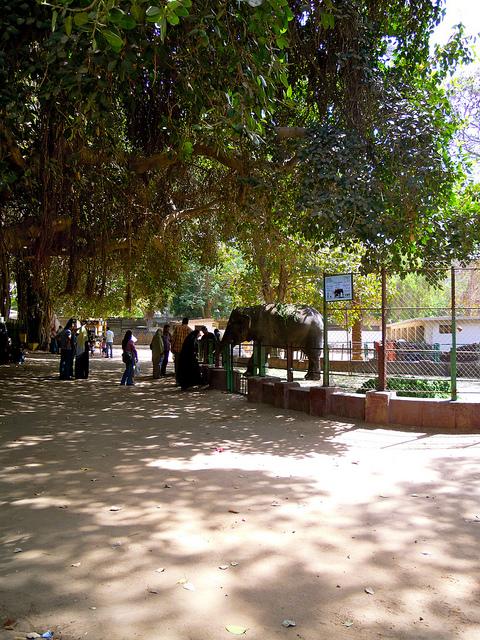What shades the people and the elephant?
Be succinct. Trees. Is this a summer scene?
Quick response, please. Yes. What is the setting of this photo?
Give a very brief answer. Zoo. Where was this picture taken?
Short answer required. Zoo. What kind of animal is in the foreground?
Quick response, please. Elephant. 